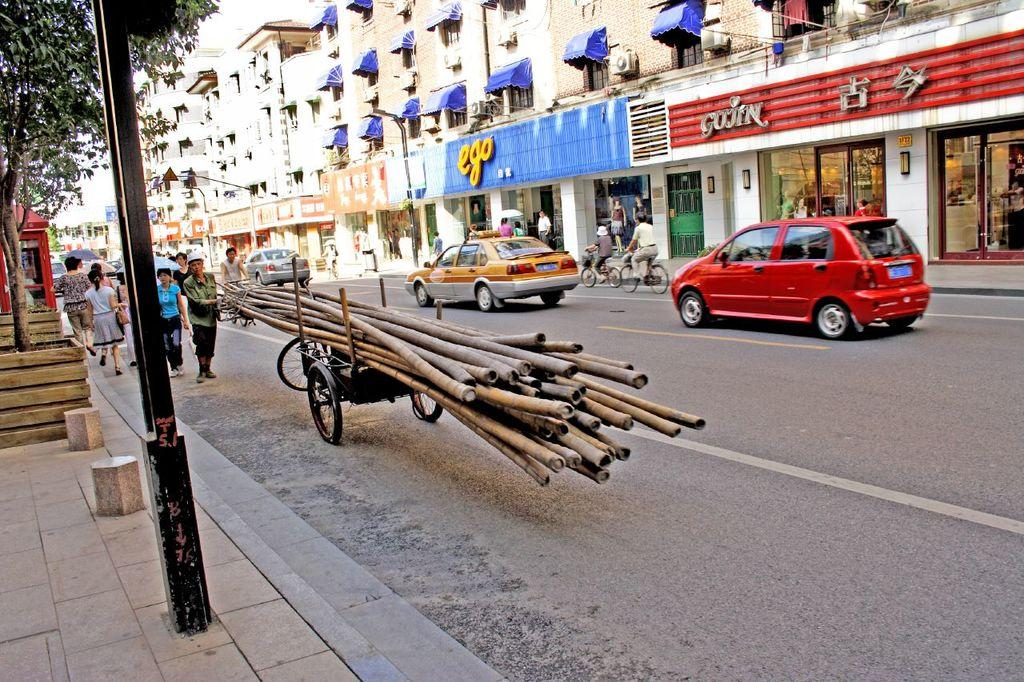Provide a one-sentence caption for the provided image. A person carrying a cart with logs on it in front of a store that says ego. 